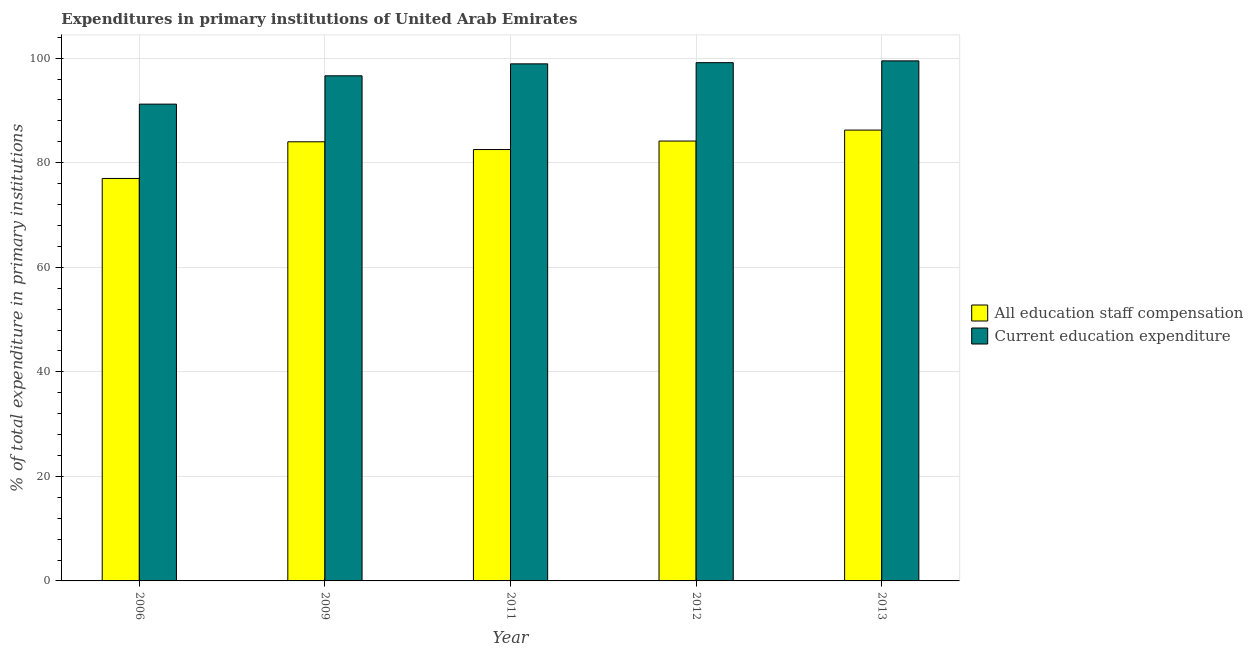How many different coloured bars are there?
Provide a short and direct response. 2. How many groups of bars are there?
Offer a terse response. 5. How many bars are there on the 1st tick from the right?
Keep it short and to the point. 2. What is the expenditure in education in 2011?
Your response must be concise. 98.91. Across all years, what is the maximum expenditure in education?
Provide a succinct answer. 99.48. Across all years, what is the minimum expenditure in education?
Your answer should be very brief. 91.21. In which year was the expenditure in education maximum?
Provide a short and direct response. 2013. In which year was the expenditure in education minimum?
Offer a terse response. 2006. What is the total expenditure in staff compensation in the graph?
Offer a very short reply. 413.91. What is the difference between the expenditure in staff compensation in 2011 and that in 2013?
Offer a very short reply. -3.72. What is the difference between the expenditure in staff compensation in 2012 and the expenditure in education in 2009?
Your response must be concise. 0.15. What is the average expenditure in staff compensation per year?
Provide a short and direct response. 82.78. In the year 2006, what is the difference between the expenditure in staff compensation and expenditure in education?
Ensure brevity in your answer.  0. In how many years, is the expenditure in staff compensation greater than 68 %?
Your answer should be very brief. 5. What is the ratio of the expenditure in staff compensation in 2009 to that in 2011?
Keep it short and to the point. 1.02. Is the difference between the expenditure in staff compensation in 2011 and 2013 greater than the difference between the expenditure in education in 2011 and 2013?
Provide a succinct answer. No. What is the difference between the highest and the second highest expenditure in education?
Give a very brief answer. 0.34. What is the difference between the highest and the lowest expenditure in staff compensation?
Provide a succinct answer. 9.25. In how many years, is the expenditure in education greater than the average expenditure in education taken over all years?
Make the answer very short. 3. What does the 1st bar from the left in 2012 represents?
Keep it short and to the point. All education staff compensation. What does the 1st bar from the right in 2012 represents?
Your answer should be very brief. Current education expenditure. Are all the bars in the graph horizontal?
Your response must be concise. No. How many years are there in the graph?
Provide a succinct answer. 5. What is the difference between two consecutive major ticks on the Y-axis?
Keep it short and to the point. 20. Are the values on the major ticks of Y-axis written in scientific E-notation?
Make the answer very short. No. Does the graph contain any zero values?
Provide a succinct answer. No. How many legend labels are there?
Ensure brevity in your answer.  2. What is the title of the graph?
Provide a succinct answer. Expenditures in primary institutions of United Arab Emirates. What is the label or title of the Y-axis?
Ensure brevity in your answer.  % of total expenditure in primary institutions. What is the % of total expenditure in primary institutions in All education staff compensation in 2006?
Your answer should be compact. 76.99. What is the % of total expenditure in primary institutions of Current education expenditure in 2006?
Your response must be concise. 91.21. What is the % of total expenditure in primary institutions in All education staff compensation in 2009?
Provide a short and direct response. 84. What is the % of total expenditure in primary institutions of Current education expenditure in 2009?
Ensure brevity in your answer.  96.63. What is the % of total expenditure in primary institutions of All education staff compensation in 2011?
Ensure brevity in your answer.  82.52. What is the % of total expenditure in primary institutions of Current education expenditure in 2011?
Give a very brief answer. 98.91. What is the % of total expenditure in primary institutions in All education staff compensation in 2012?
Your answer should be very brief. 84.15. What is the % of total expenditure in primary institutions in Current education expenditure in 2012?
Offer a terse response. 99.14. What is the % of total expenditure in primary institutions in All education staff compensation in 2013?
Your answer should be compact. 86.24. What is the % of total expenditure in primary institutions in Current education expenditure in 2013?
Give a very brief answer. 99.48. Across all years, what is the maximum % of total expenditure in primary institutions of All education staff compensation?
Provide a short and direct response. 86.24. Across all years, what is the maximum % of total expenditure in primary institutions in Current education expenditure?
Make the answer very short. 99.48. Across all years, what is the minimum % of total expenditure in primary institutions in All education staff compensation?
Provide a succinct answer. 76.99. Across all years, what is the minimum % of total expenditure in primary institutions of Current education expenditure?
Your response must be concise. 91.21. What is the total % of total expenditure in primary institutions in All education staff compensation in the graph?
Your answer should be compact. 413.91. What is the total % of total expenditure in primary institutions of Current education expenditure in the graph?
Your response must be concise. 485.38. What is the difference between the % of total expenditure in primary institutions in All education staff compensation in 2006 and that in 2009?
Keep it short and to the point. -7.01. What is the difference between the % of total expenditure in primary institutions of Current education expenditure in 2006 and that in 2009?
Offer a terse response. -5.42. What is the difference between the % of total expenditure in primary institutions in All education staff compensation in 2006 and that in 2011?
Provide a succinct answer. -5.53. What is the difference between the % of total expenditure in primary institutions in Current education expenditure in 2006 and that in 2011?
Your response must be concise. -7.7. What is the difference between the % of total expenditure in primary institutions in All education staff compensation in 2006 and that in 2012?
Your answer should be compact. -7.16. What is the difference between the % of total expenditure in primary institutions of Current education expenditure in 2006 and that in 2012?
Give a very brief answer. -7.93. What is the difference between the % of total expenditure in primary institutions in All education staff compensation in 2006 and that in 2013?
Your answer should be compact. -9.25. What is the difference between the % of total expenditure in primary institutions of Current education expenditure in 2006 and that in 2013?
Your answer should be compact. -8.27. What is the difference between the % of total expenditure in primary institutions of All education staff compensation in 2009 and that in 2011?
Your response must be concise. 1.48. What is the difference between the % of total expenditure in primary institutions in Current education expenditure in 2009 and that in 2011?
Ensure brevity in your answer.  -2.28. What is the difference between the % of total expenditure in primary institutions in All education staff compensation in 2009 and that in 2012?
Your response must be concise. -0.15. What is the difference between the % of total expenditure in primary institutions in Current education expenditure in 2009 and that in 2012?
Your answer should be compact. -2.51. What is the difference between the % of total expenditure in primary institutions in All education staff compensation in 2009 and that in 2013?
Ensure brevity in your answer.  -2.24. What is the difference between the % of total expenditure in primary institutions in Current education expenditure in 2009 and that in 2013?
Your answer should be compact. -2.85. What is the difference between the % of total expenditure in primary institutions in All education staff compensation in 2011 and that in 2012?
Offer a terse response. -1.63. What is the difference between the % of total expenditure in primary institutions in Current education expenditure in 2011 and that in 2012?
Make the answer very short. -0.23. What is the difference between the % of total expenditure in primary institutions of All education staff compensation in 2011 and that in 2013?
Offer a very short reply. -3.72. What is the difference between the % of total expenditure in primary institutions of Current education expenditure in 2011 and that in 2013?
Your answer should be very brief. -0.57. What is the difference between the % of total expenditure in primary institutions of All education staff compensation in 2012 and that in 2013?
Ensure brevity in your answer.  -2.09. What is the difference between the % of total expenditure in primary institutions of Current education expenditure in 2012 and that in 2013?
Offer a terse response. -0.34. What is the difference between the % of total expenditure in primary institutions in All education staff compensation in 2006 and the % of total expenditure in primary institutions in Current education expenditure in 2009?
Give a very brief answer. -19.64. What is the difference between the % of total expenditure in primary institutions in All education staff compensation in 2006 and the % of total expenditure in primary institutions in Current education expenditure in 2011?
Provide a short and direct response. -21.92. What is the difference between the % of total expenditure in primary institutions of All education staff compensation in 2006 and the % of total expenditure in primary institutions of Current education expenditure in 2012?
Keep it short and to the point. -22.15. What is the difference between the % of total expenditure in primary institutions of All education staff compensation in 2006 and the % of total expenditure in primary institutions of Current education expenditure in 2013?
Give a very brief answer. -22.49. What is the difference between the % of total expenditure in primary institutions in All education staff compensation in 2009 and the % of total expenditure in primary institutions in Current education expenditure in 2011?
Ensure brevity in your answer.  -14.91. What is the difference between the % of total expenditure in primary institutions in All education staff compensation in 2009 and the % of total expenditure in primary institutions in Current education expenditure in 2012?
Your answer should be very brief. -15.14. What is the difference between the % of total expenditure in primary institutions of All education staff compensation in 2009 and the % of total expenditure in primary institutions of Current education expenditure in 2013?
Offer a very short reply. -15.48. What is the difference between the % of total expenditure in primary institutions of All education staff compensation in 2011 and the % of total expenditure in primary institutions of Current education expenditure in 2012?
Make the answer very short. -16.62. What is the difference between the % of total expenditure in primary institutions in All education staff compensation in 2011 and the % of total expenditure in primary institutions in Current education expenditure in 2013?
Your answer should be compact. -16.96. What is the difference between the % of total expenditure in primary institutions in All education staff compensation in 2012 and the % of total expenditure in primary institutions in Current education expenditure in 2013?
Your answer should be very brief. -15.33. What is the average % of total expenditure in primary institutions of All education staff compensation per year?
Your answer should be very brief. 82.78. What is the average % of total expenditure in primary institutions in Current education expenditure per year?
Your answer should be very brief. 97.08. In the year 2006, what is the difference between the % of total expenditure in primary institutions in All education staff compensation and % of total expenditure in primary institutions in Current education expenditure?
Your response must be concise. -14.22. In the year 2009, what is the difference between the % of total expenditure in primary institutions of All education staff compensation and % of total expenditure in primary institutions of Current education expenditure?
Provide a short and direct response. -12.62. In the year 2011, what is the difference between the % of total expenditure in primary institutions of All education staff compensation and % of total expenditure in primary institutions of Current education expenditure?
Provide a succinct answer. -16.39. In the year 2012, what is the difference between the % of total expenditure in primary institutions in All education staff compensation and % of total expenditure in primary institutions in Current education expenditure?
Keep it short and to the point. -14.99. In the year 2013, what is the difference between the % of total expenditure in primary institutions in All education staff compensation and % of total expenditure in primary institutions in Current education expenditure?
Your response must be concise. -13.24. What is the ratio of the % of total expenditure in primary institutions of All education staff compensation in 2006 to that in 2009?
Offer a very short reply. 0.92. What is the ratio of the % of total expenditure in primary institutions in Current education expenditure in 2006 to that in 2009?
Keep it short and to the point. 0.94. What is the ratio of the % of total expenditure in primary institutions of All education staff compensation in 2006 to that in 2011?
Your answer should be very brief. 0.93. What is the ratio of the % of total expenditure in primary institutions in Current education expenditure in 2006 to that in 2011?
Offer a very short reply. 0.92. What is the ratio of the % of total expenditure in primary institutions in All education staff compensation in 2006 to that in 2012?
Give a very brief answer. 0.91. What is the ratio of the % of total expenditure in primary institutions in Current education expenditure in 2006 to that in 2012?
Your answer should be compact. 0.92. What is the ratio of the % of total expenditure in primary institutions of All education staff compensation in 2006 to that in 2013?
Provide a short and direct response. 0.89. What is the ratio of the % of total expenditure in primary institutions of Current education expenditure in 2006 to that in 2013?
Provide a succinct answer. 0.92. What is the ratio of the % of total expenditure in primary institutions of All education staff compensation in 2009 to that in 2011?
Give a very brief answer. 1.02. What is the ratio of the % of total expenditure in primary institutions of Current education expenditure in 2009 to that in 2011?
Your answer should be very brief. 0.98. What is the ratio of the % of total expenditure in primary institutions of Current education expenditure in 2009 to that in 2012?
Your answer should be compact. 0.97. What is the ratio of the % of total expenditure in primary institutions in Current education expenditure in 2009 to that in 2013?
Your answer should be compact. 0.97. What is the ratio of the % of total expenditure in primary institutions in All education staff compensation in 2011 to that in 2012?
Offer a very short reply. 0.98. What is the ratio of the % of total expenditure in primary institutions of All education staff compensation in 2011 to that in 2013?
Keep it short and to the point. 0.96. What is the ratio of the % of total expenditure in primary institutions of Current education expenditure in 2011 to that in 2013?
Provide a succinct answer. 0.99. What is the ratio of the % of total expenditure in primary institutions in All education staff compensation in 2012 to that in 2013?
Make the answer very short. 0.98. What is the ratio of the % of total expenditure in primary institutions of Current education expenditure in 2012 to that in 2013?
Provide a succinct answer. 1. What is the difference between the highest and the second highest % of total expenditure in primary institutions of All education staff compensation?
Your answer should be compact. 2.09. What is the difference between the highest and the second highest % of total expenditure in primary institutions of Current education expenditure?
Provide a succinct answer. 0.34. What is the difference between the highest and the lowest % of total expenditure in primary institutions of All education staff compensation?
Your answer should be compact. 9.25. What is the difference between the highest and the lowest % of total expenditure in primary institutions in Current education expenditure?
Your answer should be compact. 8.27. 